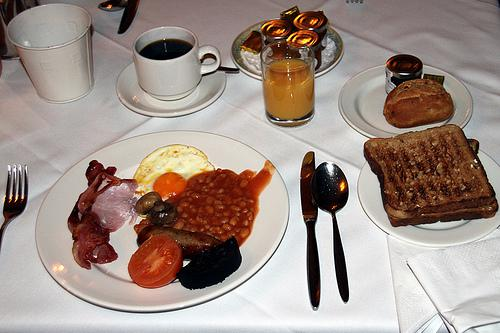Question: how many glasses are pictured?
Choices:
A. Three.
B. Two.
C. One.
D. Four.
Answer with the letter. Answer: A Question: how many knives are pictured?
Choices:
A. Two.
B. Three.
C. One.
D. Four.
Answer with the letter. Answer: C Question: how many cups are empty?
Choices:
A. One.
B. Two.
C. Three.
D. Four.
Answer with the letter. Answer: A Question: what color liquid is in the rightmost cup?
Choices:
A. Red.
B. Pink.
C. Purple.
D. Orange.
Answer with the letter. Answer: D Question: how many plates are pictured?
Choices:
A. 3.
B. 6.
C. 8.
D. 5.
Answer with the letter. Answer: D 